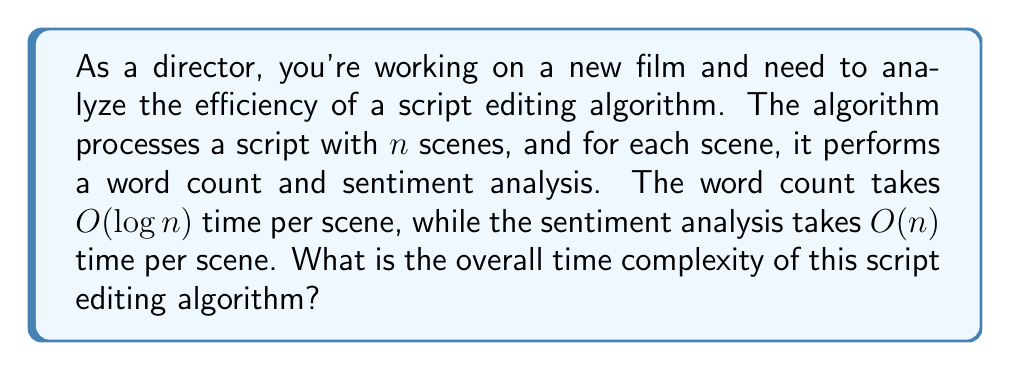Provide a solution to this math problem. Let's break down the problem and analyze it step by step:

1. We have $n$ scenes in the script.

2. For each scene, two operations are performed:
   a. Word count: $O(\log n)$ time
   b. Sentiment analysis: $O(n)$ time

3. The total time for processing one scene is:
   $O(\log n) + O(n) = O(n)$ (since $O(n)$ dominates $O(\log n)$)

4. Since we perform these operations for all $n$ scenes, we multiply the time per scene by $n$:
   $n \cdot O(n) = O(n^2)$

5. Therefore, the overall time complexity of the algorithm is $O(n^2)$.

This quadratic time complexity suggests that the algorithm's running time grows rapidly as the number of scenes increases. As a director and producer, you might want to consider optimizing this algorithm, especially for longer scripts, to improve the editing process efficiency.
Answer: The overall time complexity of the script editing algorithm is $O(n^2)$. 